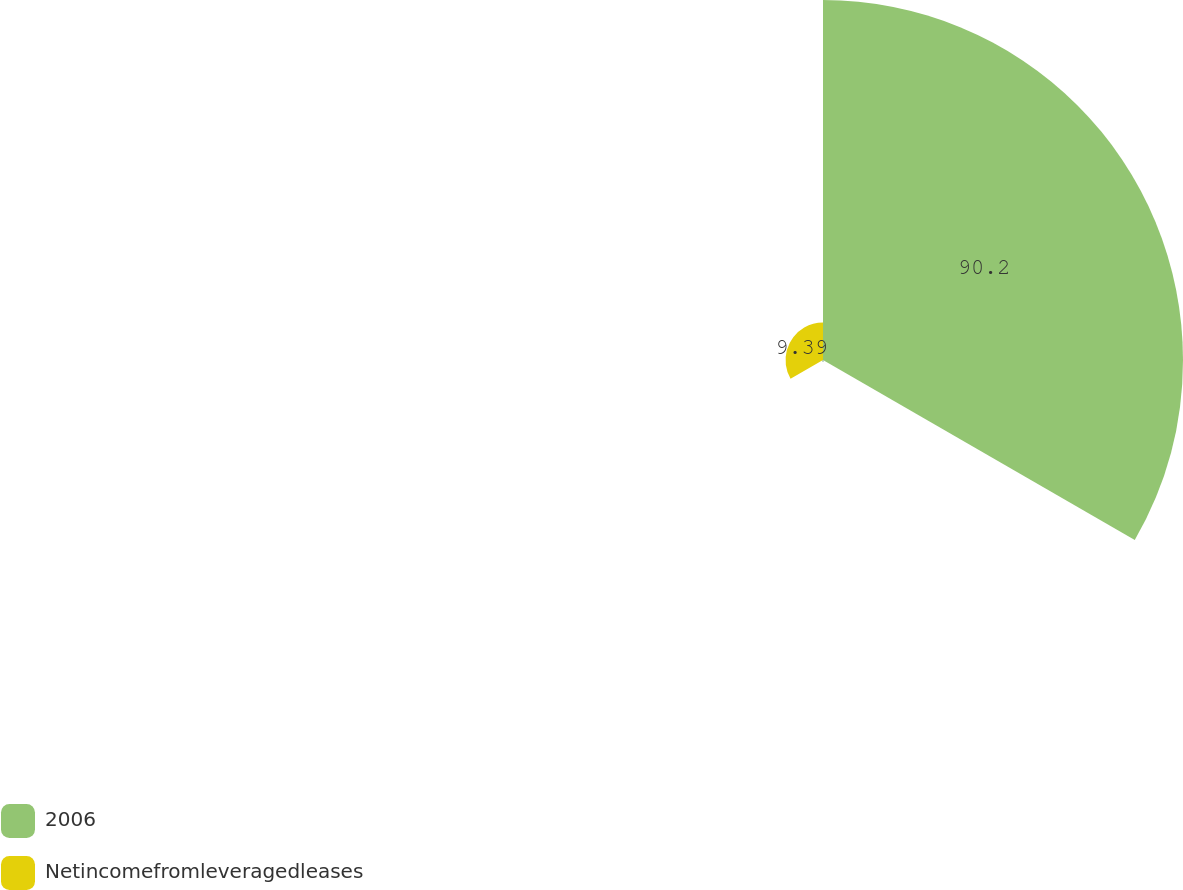<chart> <loc_0><loc_0><loc_500><loc_500><pie_chart><fcel>2006<fcel>Unnamed: 1<fcel>Netincomefromleveragedleases<nl><fcel>90.21%<fcel>0.41%<fcel>9.39%<nl></chart> 